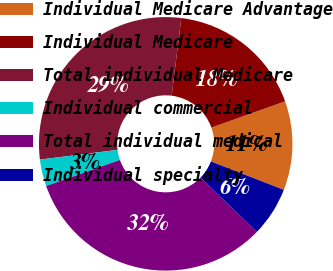Convert chart. <chart><loc_0><loc_0><loc_500><loc_500><pie_chart><fcel>Individual Medicare Advantage<fcel>Individual Medicare<fcel>Total individual Medicare<fcel>Individual commercial<fcel>Total individual medical<fcel>Individual specialty<nl><fcel>11.36%<fcel>17.59%<fcel>28.95%<fcel>3.42%<fcel>32.37%<fcel>6.31%<nl></chart> 